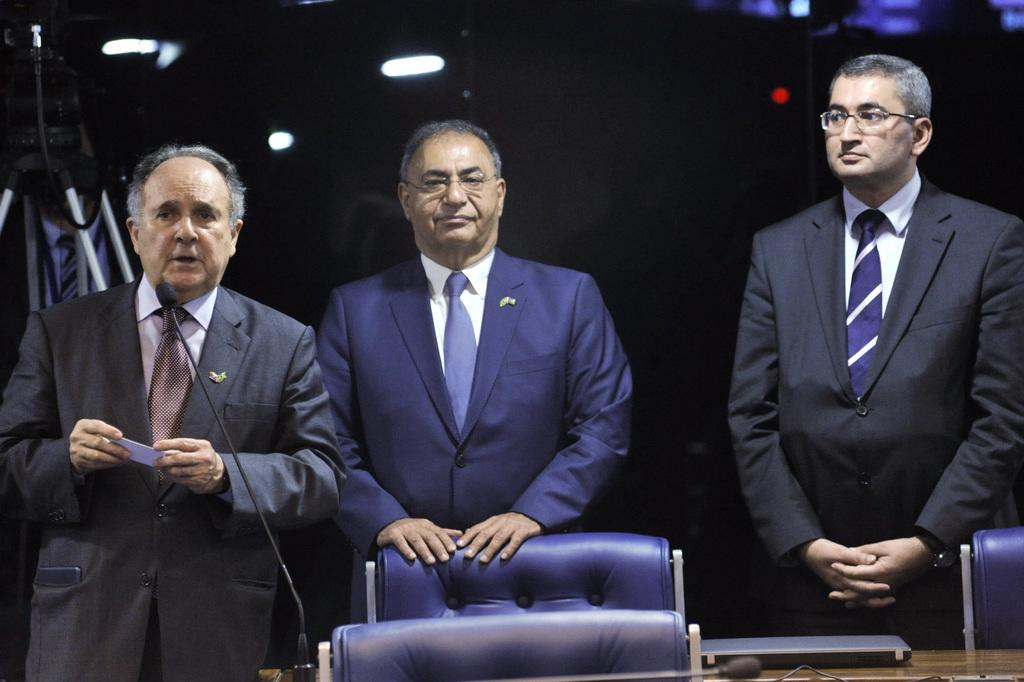How many men are in the image? There are three men in the image. What are the men wearing in the image? Each man is wearing a blazer and a tie. What objects are in front of the men? There is a laptop and microphones in front of the men. What can be seen in the background of the image? There are lights visible in the background, and the background appears to be dark. Can you tell me how many cats are sitting on the men's laps in the image? There are no cats present in the image; the men are not holding or interacting with any cats. 